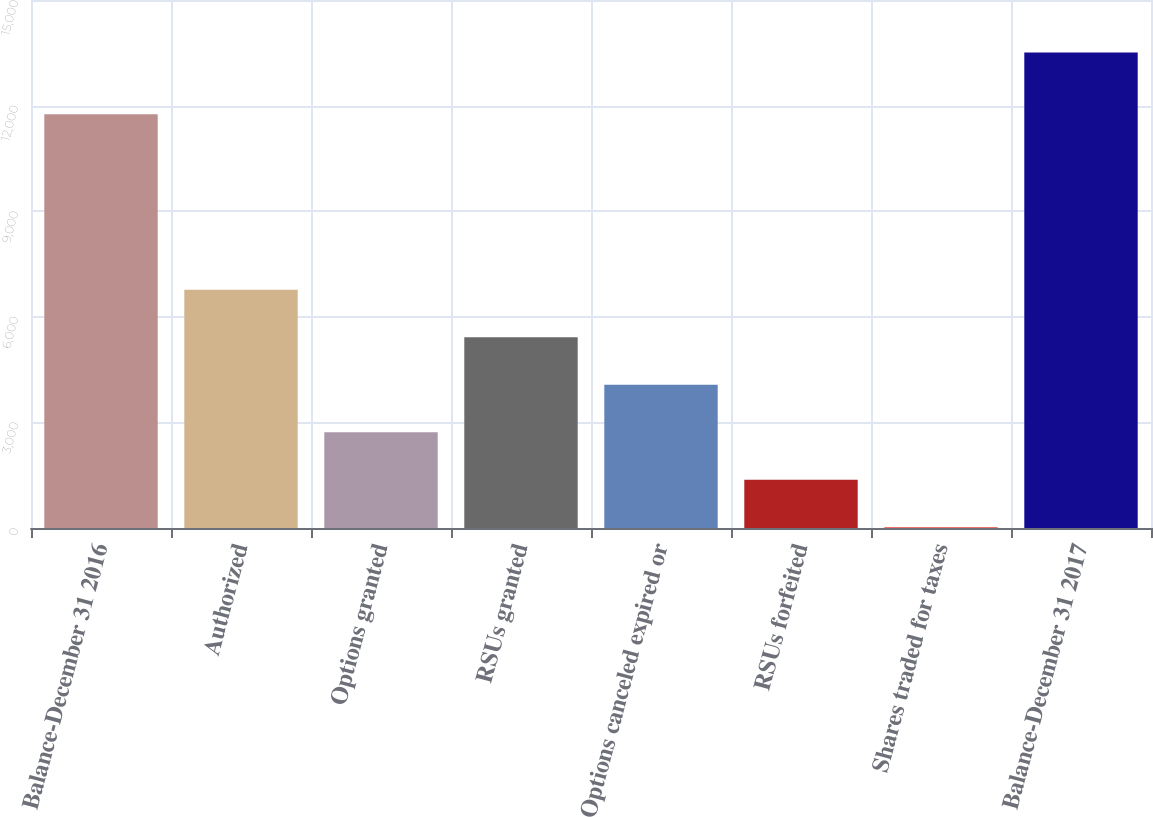<chart> <loc_0><loc_0><loc_500><loc_500><bar_chart><fcel>Balance-December 31 2016<fcel>Authorized<fcel>Options granted<fcel>RSUs granted<fcel>Options canceled expired or<fcel>RSUs forfeited<fcel>Shares traded for taxes<fcel>Balance-December 31 2017<nl><fcel>11754<fcel>6767.5<fcel>2720.8<fcel>5418.6<fcel>4069.7<fcel>1371.9<fcel>23<fcel>13512<nl></chart> 